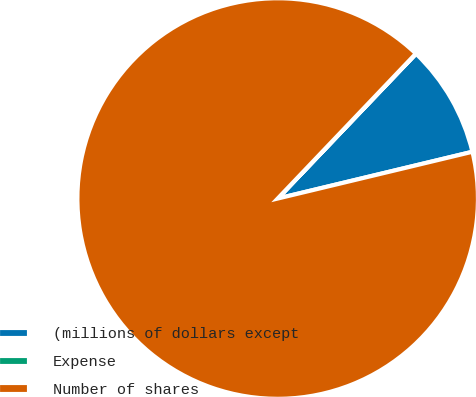Convert chart. <chart><loc_0><loc_0><loc_500><loc_500><pie_chart><fcel>(millions of dollars except<fcel>Expense<fcel>Number of shares<nl><fcel>9.11%<fcel>0.02%<fcel>90.87%<nl></chart> 